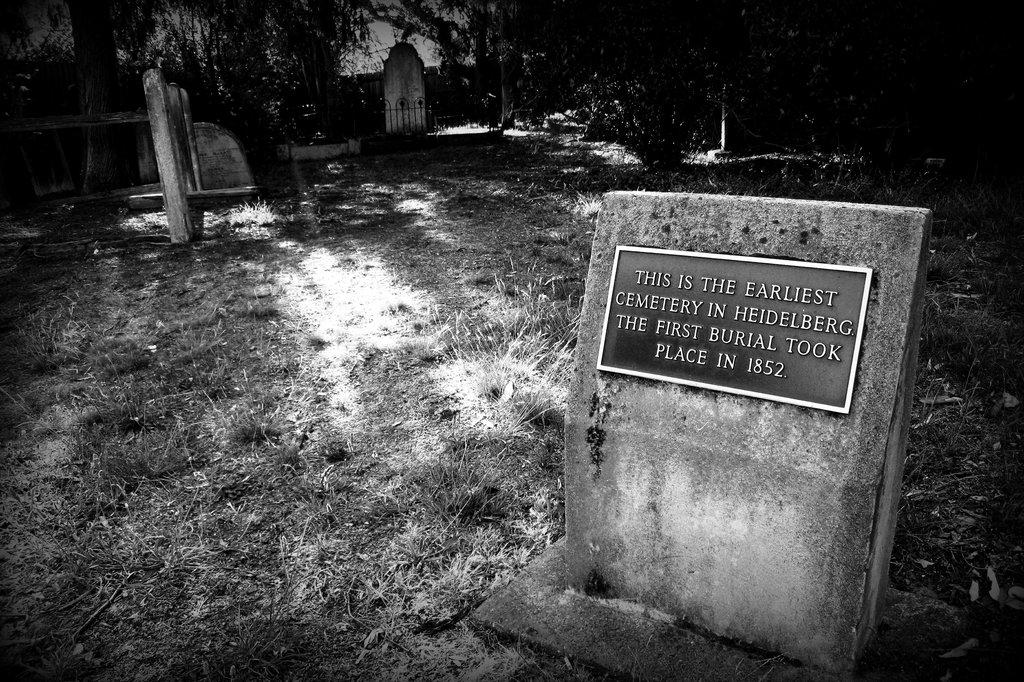What is the color scheme of the image? The image is black and white. Where was the image taken? The image was taken in a cemetery. What type of vegetation can be seen in the image? There are shrubs in the image. What are the main features of the cemetery in the image? There are gravestones in the image. What can be seen in the background of the image? There are trees in the background of the image. What type of boot is being polished by the person in the image? There is no person or boot present in the image; it is a black and white photograph of a cemetery. 